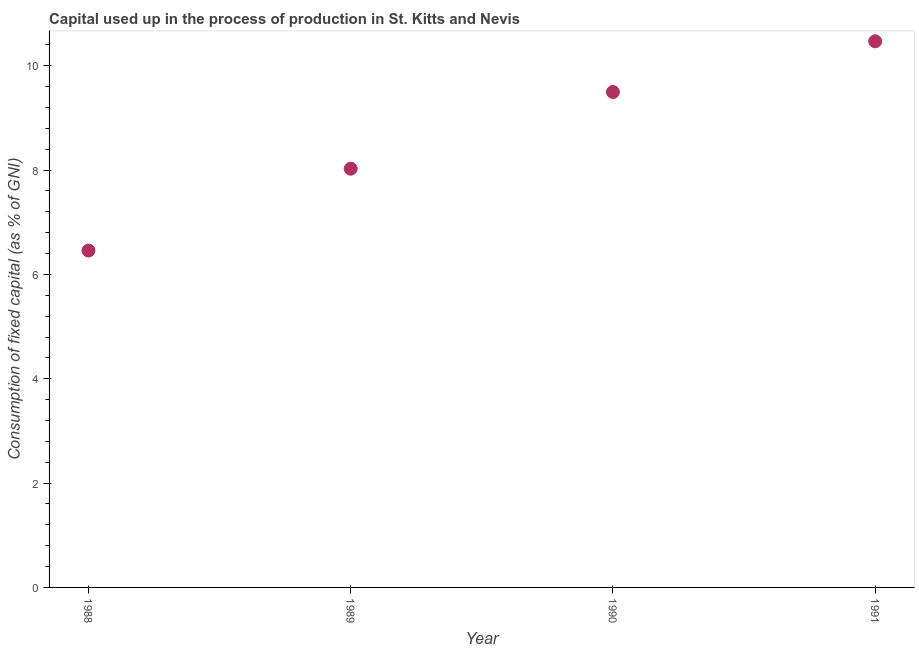What is the consumption of fixed capital in 1989?
Make the answer very short. 8.03. Across all years, what is the maximum consumption of fixed capital?
Give a very brief answer. 10.47. Across all years, what is the minimum consumption of fixed capital?
Keep it short and to the point. 6.46. In which year was the consumption of fixed capital minimum?
Make the answer very short. 1988. What is the sum of the consumption of fixed capital?
Provide a succinct answer. 34.45. What is the difference between the consumption of fixed capital in 1989 and 1991?
Your response must be concise. -2.44. What is the average consumption of fixed capital per year?
Keep it short and to the point. 8.61. What is the median consumption of fixed capital?
Keep it short and to the point. 8.76. Do a majority of the years between 1991 and 1989 (inclusive) have consumption of fixed capital greater than 8.8 %?
Provide a succinct answer. No. What is the ratio of the consumption of fixed capital in 1989 to that in 1990?
Keep it short and to the point. 0.85. Is the consumption of fixed capital in 1989 less than that in 1991?
Keep it short and to the point. Yes. Is the difference between the consumption of fixed capital in 1989 and 1990 greater than the difference between any two years?
Offer a very short reply. No. What is the difference between the highest and the second highest consumption of fixed capital?
Offer a terse response. 0.97. What is the difference between the highest and the lowest consumption of fixed capital?
Your response must be concise. 4.01. In how many years, is the consumption of fixed capital greater than the average consumption of fixed capital taken over all years?
Offer a very short reply. 2. Does the consumption of fixed capital monotonically increase over the years?
Offer a terse response. Yes. Does the graph contain grids?
Your answer should be compact. No. What is the title of the graph?
Provide a succinct answer. Capital used up in the process of production in St. Kitts and Nevis. What is the label or title of the X-axis?
Provide a succinct answer. Year. What is the label or title of the Y-axis?
Make the answer very short. Consumption of fixed capital (as % of GNI). What is the Consumption of fixed capital (as % of GNI) in 1988?
Provide a succinct answer. 6.46. What is the Consumption of fixed capital (as % of GNI) in 1989?
Your answer should be compact. 8.03. What is the Consumption of fixed capital (as % of GNI) in 1990?
Provide a short and direct response. 9.5. What is the Consumption of fixed capital (as % of GNI) in 1991?
Give a very brief answer. 10.47. What is the difference between the Consumption of fixed capital (as % of GNI) in 1988 and 1989?
Keep it short and to the point. -1.57. What is the difference between the Consumption of fixed capital (as % of GNI) in 1988 and 1990?
Your answer should be compact. -3.04. What is the difference between the Consumption of fixed capital (as % of GNI) in 1988 and 1991?
Your answer should be very brief. -4.01. What is the difference between the Consumption of fixed capital (as % of GNI) in 1989 and 1990?
Make the answer very short. -1.47. What is the difference between the Consumption of fixed capital (as % of GNI) in 1989 and 1991?
Provide a succinct answer. -2.44. What is the difference between the Consumption of fixed capital (as % of GNI) in 1990 and 1991?
Make the answer very short. -0.97. What is the ratio of the Consumption of fixed capital (as % of GNI) in 1988 to that in 1989?
Make the answer very short. 0.8. What is the ratio of the Consumption of fixed capital (as % of GNI) in 1988 to that in 1990?
Ensure brevity in your answer.  0.68. What is the ratio of the Consumption of fixed capital (as % of GNI) in 1988 to that in 1991?
Ensure brevity in your answer.  0.62. What is the ratio of the Consumption of fixed capital (as % of GNI) in 1989 to that in 1990?
Provide a succinct answer. 0.84. What is the ratio of the Consumption of fixed capital (as % of GNI) in 1989 to that in 1991?
Ensure brevity in your answer.  0.77. What is the ratio of the Consumption of fixed capital (as % of GNI) in 1990 to that in 1991?
Ensure brevity in your answer.  0.91. 